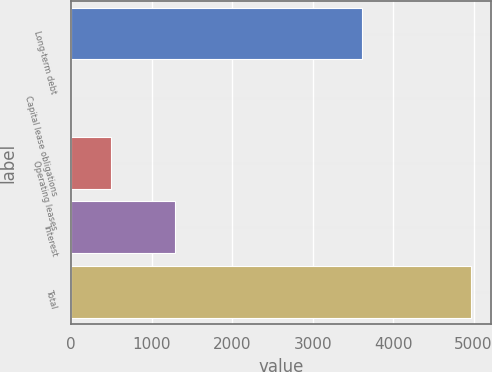<chart> <loc_0><loc_0><loc_500><loc_500><bar_chart><fcel>Long-term debt<fcel>Capital lease obligations<fcel>Operating leases<fcel>Interest<fcel>Total<nl><fcel>3608<fcel>2<fcel>498.6<fcel>1287<fcel>4968<nl></chart> 